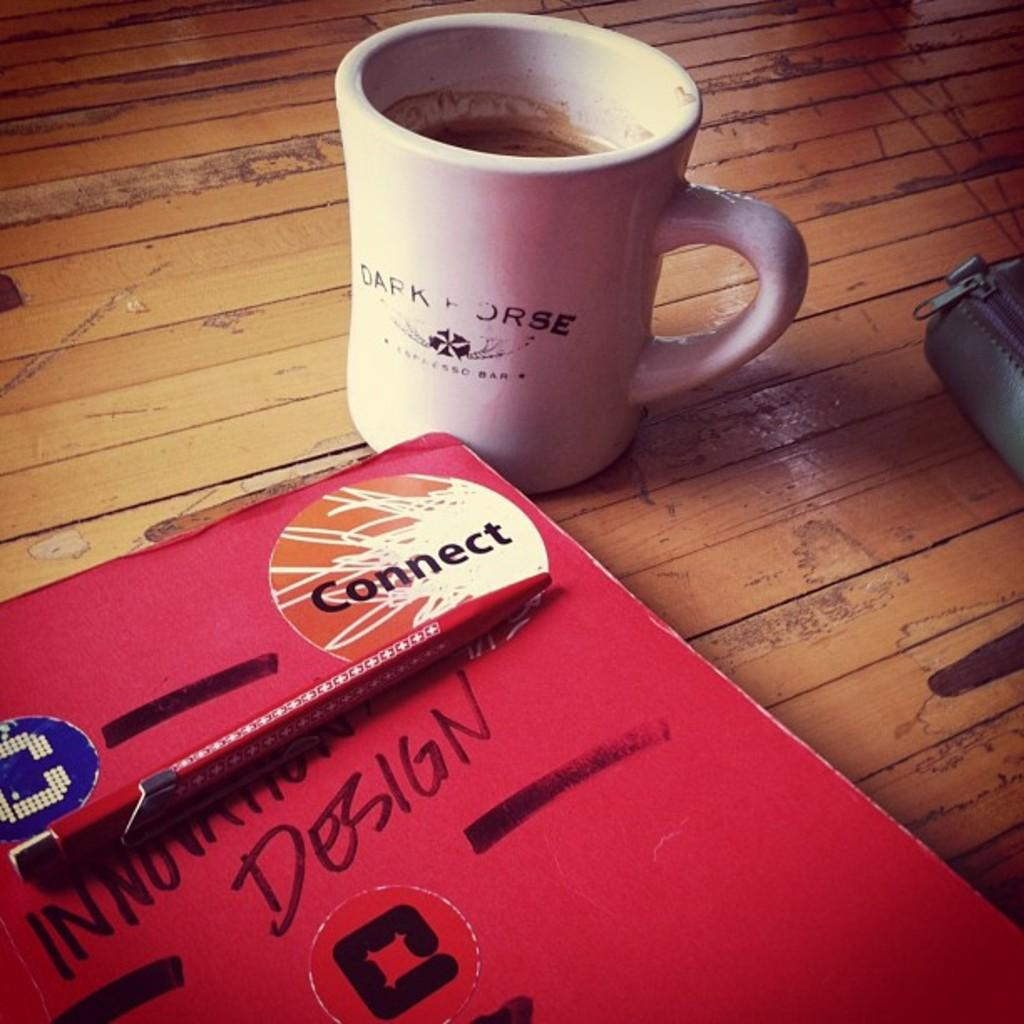Provide a one-sentence caption for the provided image. A Connect sticker is in the corner of a book labeled Innovation Design. 